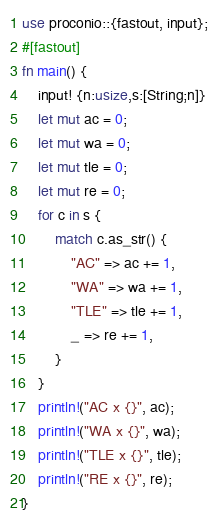Convert code to text. <code><loc_0><loc_0><loc_500><loc_500><_Rust_>use proconio::{fastout, input};
#[fastout]
fn main() {
    input! {n:usize,s:[String;n]}
    let mut ac = 0;
    let mut wa = 0;
    let mut tle = 0;
    let mut re = 0;
    for c in s {
        match c.as_str() {
            "AC" => ac += 1,
            "WA" => wa += 1,
            "TLE" => tle += 1,
            _ => re += 1,
        }
    }
    println!("AC x {}", ac);
    println!("WA x {}", wa);
    println!("TLE x {}", tle);
    println!("RE x {}", re);
}
</code> 